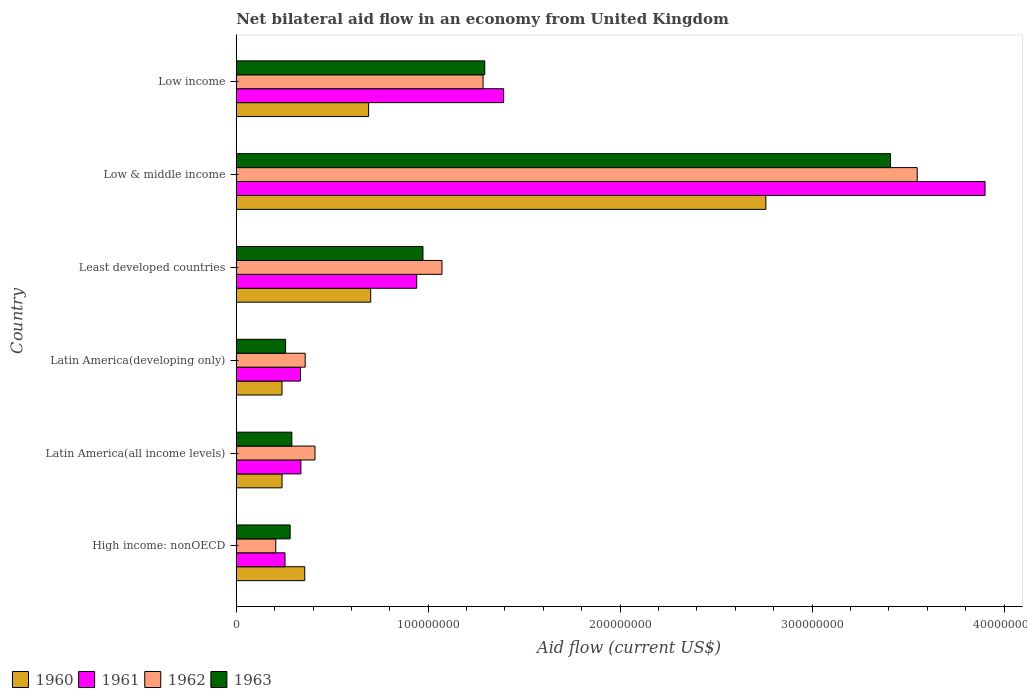How many bars are there on the 2nd tick from the top?
Make the answer very short. 4. How many bars are there on the 6th tick from the bottom?
Offer a terse response. 4. What is the label of the 5th group of bars from the top?
Offer a very short reply. Latin America(all income levels). In how many cases, is the number of bars for a given country not equal to the number of legend labels?
Your answer should be compact. 0. What is the net bilateral aid flow in 1963 in Least developed countries?
Your answer should be very brief. 9.73e+07. Across all countries, what is the maximum net bilateral aid flow in 1963?
Provide a succinct answer. 3.41e+08. Across all countries, what is the minimum net bilateral aid flow in 1960?
Provide a succinct answer. 2.38e+07. In which country was the net bilateral aid flow in 1960 minimum?
Provide a succinct answer. Latin America(developing only). What is the total net bilateral aid flow in 1962 in the graph?
Your answer should be compact. 6.88e+08. What is the difference between the net bilateral aid flow in 1963 in Low & middle income and that in Low income?
Ensure brevity in your answer.  2.11e+08. What is the difference between the net bilateral aid flow in 1961 in Latin America(all income levels) and the net bilateral aid flow in 1962 in Low & middle income?
Your answer should be compact. -3.21e+08. What is the average net bilateral aid flow in 1960 per country?
Your answer should be compact. 8.30e+07. What is the difference between the net bilateral aid flow in 1963 and net bilateral aid flow in 1960 in Least developed countries?
Keep it short and to the point. 2.72e+07. What is the ratio of the net bilateral aid flow in 1961 in Least developed countries to that in Low & middle income?
Your response must be concise. 0.24. Is the difference between the net bilateral aid flow in 1963 in High income: nonOECD and Low income greater than the difference between the net bilateral aid flow in 1960 in High income: nonOECD and Low income?
Your answer should be compact. No. What is the difference between the highest and the second highest net bilateral aid flow in 1962?
Make the answer very short. 2.26e+08. What is the difference between the highest and the lowest net bilateral aid flow in 1962?
Provide a succinct answer. 3.34e+08. In how many countries, is the net bilateral aid flow in 1961 greater than the average net bilateral aid flow in 1961 taken over all countries?
Provide a succinct answer. 2. What does the 3rd bar from the bottom in Latin America(all income levels) represents?
Offer a terse response. 1962. How many countries are there in the graph?
Provide a short and direct response. 6. Are the values on the major ticks of X-axis written in scientific E-notation?
Provide a short and direct response. No. Does the graph contain any zero values?
Make the answer very short. No. Where does the legend appear in the graph?
Ensure brevity in your answer.  Bottom left. How are the legend labels stacked?
Offer a very short reply. Horizontal. What is the title of the graph?
Your answer should be compact. Net bilateral aid flow in an economy from United Kingdom. Does "2001" appear as one of the legend labels in the graph?
Your answer should be very brief. No. What is the label or title of the X-axis?
Ensure brevity in your answer.  Aid flow (current US$). What is the label or title of the Y-axis?
Your answer should be compact. Country. What is the Aid flow (current US$) of 1960 in High income: nonOECD?
Your response must be concise. 3.57e+07. What is the Aid flow (current US$) in 1961 in High income: nonOECD?
Provide a succinct answer. 2.54e+07. What is the Aid flow (current US$) of 1962 in High income: nonOECD?
Your answer should be very brief. 2.06e+07. What is the Aid flow (current US$) of 1963 in High income: nonOECD?
Your answer should be compact. 2.81e+07. What is the Aid flow (current US$) of 1960 in Latin America(all income levels)?
Ensure brevity in your answer.  2.39e+07. What is the Aid flow (current US$) in 1961 in Latin America(all income levels)?
Provide a short and direct response. 3.37e+07. What is the Aid flow (current US$) of 1962 in Latin America(all income levels)?
Provide a succinct answer. 4.10e+07. What is the Aid flow (current US$) in 1963 in Latin America(all income levels)?
Ensure brevity in your answer.  2.90e+07. What is the Aid flow (current US$) of 1960 in Latin America(developing only)?
Your answer should be very brief. 2.38e+07. What is the Aid flow (current US$) of 1961 in Latin America(developing only)?
Your answer should be compact. 3.34e+07. What is the Aid flow (current US$) of 1962 in Latin America(developing only)?
Make the answer very short. 3.59e+07. What is the Aid flow (current US$) in 1963 in Latin America(developing only)?
Offer a very short reply. 2.57e+07. What is the Aid flow (current US$) in 1960 in Least developed countries?
Offer a very short reply. 7.00e+07. What is the Aid flow (current US$) in 1961 in Least developed countries?
Your response must be concise. 9.40e+07. What is the Aid flow (current US$) of 1962 in Least developed countries?
Ensure brevity in your answer.  1.07e+08. What is the Aid flow (current US$) in 1963 in Least developed countries?
Provide a succinct answer. 9.73e+07. What is the Aid flow (current US$) in 1960 in Low & middle income?
Offer a terse response. 2.76e+08. What is the Aid flow (current US$) in 1961 in Low & middle income?
Offer a very short reply. 3.90e+08. What is the Aid flow (current US$) of 1962 in Low & middle income?
Your response must be concise. 3.55e+08. What is the Aid flow (current US$) of 1963 in Low & middle income?
Provide a succinct answer. 3.41e+08. What is the Aid flow (current US$) in 1960 in Low income?
Provide a short and direct response. 6.90e+07. What is the Aid flow (current US$) in 1961 in Low income?
Your answer should be very brief. 1.39e+08. What is the Aid flow (current US$) in 1962 in Low income?
Offer a terse response. 1.29e+08. What is the Aid flow (current US$) of 1963 in Low income?
Offer a very short reply. 1.29e+08. Across all countries, what is the maximum Aid flow (current US$) in 1960?
Give a very brief answer. 2.76e+08. Across all countries, what is the maximum Aid flow (current US$) in 1961?
Provide a short and direct response. 3.90e+08. Across all countries, what is the maximum Aid flow (current US$) in 1962?
Ensure brevity in your answer.  3.55e+08. Across all countries, what is the maximum Aid flow (current US$) in 1963?
Your answer should be compact. 3.41e+08. Across all countries, what is the minimum Aid flow (current US$) of 1960?
Your response must be concise. 2.38e+07. Across all countries, what is the minimum Aid flow (current US$) of 1961?
Your answer should be compact. 2.54e+07. Across all countries, what is the minimum Aid flow (current US$) in 1962?
Your answer should be very brief. 2.06e+07. Across all countries, what is the minimum Aid flow (current US$) in 1963?
Provide a succinct answer. 2.57e+07. What is the total Aid flow (current US$) of 1960 in the graph?
Give a very brief answer. 4.98e+08. What is the total Aid flow (current US$) in 1961 in the graph?
Give a very brief answer. 7.16e+08. What is the total Aid flow (current US$) in 1962 in the graph?
Your answer should be very brief. 6.88e+08. What is the total Aid flow (current US$) of 1963 in the graph?
Ensure brevity in your answer.  6.50e+08. What is the difference between the Aid flow (current US$) of 1960 in High income: nonOECD and that in Latin America(all income levels)?
Provide a short and direct response. 1.18e+07. What is the difference between the Aid flow (current US$) of 1961 in High income: nonOECD and that in Latin America(all income levels)?
Give a very brief answer. -8.27e+06. What is the difference between the Aid flow (current US$) of 1962 in High income: nonOECD and that in Latin America(all income levels)?
Give a very brief answer. -2.04e+07. What is the difference between the Aid flow (current US$) in 1963 in High income: nonOECD and that in Latin America(all income levels)?
Offer a very short reply. -9.00e+05. What is the difference between the Aid flow (current US$) in 1960 in High income: nonOECD and that in Latin America(developing only)?
Your response must be concise. 1.18e+07. What is the difference between the Aid flow (current US$) of 1961 in High income: nonOECD and that in Latin America(developing only)?
Ensure brevity in your answer.  -8.05e+06. What is the difference between the Aid flow (current US$) of 1962 in High income: nonOECD and that in Latin America(developing only)?
Your answer should be very brief. -1.53e+07. What is the difference between the Aid flow (current US$) in 1963 in High income: nonOECD and that in Latin America(developing only)?
Your answer should be very brief. 2.35e+06. What is the difference between the Aid flow (current US$) in 1960 in High income: nonOECD and that in Least developed countries?
Your answer should be very brief. -3.44e+07. What is the difference between the Aid flow (current US$) of 1961 in High income: nonOECD and that in Least developed countries?
Provide a succinct answer. -6.86e+07. What is the difference between the Aid flow (current US$) of 1962 in High income: nonOECD and that in Least developed countries?
Provide a short and direct response. -8.66e+07. What is the difference between the Aid flow (current US$) of 1963 in High income: nonOECD and that in Least developed countries?
Provide a short and direct response. -6.92e+07. What is the difference between the Aid flow (current US$) of 1960 in High income: nonOECD and that in Low & middle income?
Offer a very short reply. -2.40e+08. What is the difference between the Aid flow (current US$) in 1961 in High income: nonOECD and that in Low & middle income?
Provide a short and direct response. -3.65e+08. What is the difference between the Aid flow (current US$) of 1962 in High income: nonOECD and that in Low & middle income?
Provide a succinct answer. -3.34e+08. What is the difference between the Aid flow (current US$) in 1963 in High income: nonOECD and that in Low & middle income?
Your answer should be very brief. -3.13e+08. What is the difference between the Aid flow (current US$) in 1960 in High income: nonOECD and that in Low income?
Offer a terse response. -3.33e+07. What is the difference between the Aid flow (current US$) of 1961 in High income: nonOECD and that in Low income?
Offer a terse response. -1.14e+08. What is the difference between the Aid flow (current US$) of 1962 in High income: nonOECD and that in Low income?
Keep it short and to the point. -1.08e+08. What is the difference between the Aid flow (current US$) in 1963 in High income: nonOECD and that in Low income?
Offer a very short reply. -1.01e+08. What is the difference between the Aid flow (current US$) in 1961 in Latin America(all income levels) and that in Latin America(developing only)?
Give a very brief answer. 2.20e+05. What is the difference between the Aid flow (current US$) in 1962 in Latin America(all income levels) and that in Latin America(developing only)?
Your response must be concise. 5.10e+06. What is the difference between the Aid flow (current US$) of 1963 in Latin America(all income levels) and that in Latin America(developing only)?
Your answer should be compact. 3.25e+06. What is the difference between the Aid flow (current US$) of 1960 in Latin America(all income levels) and that in Least developed countries?
Provide a short and direct response. -4.62e+07. What is the difference between the Aid flow (current US$) in 1961 in Latin America(all income levels) and that in Least developed countries?
Offer a terse response. -6.04e+07. What is the difference between the Aid flow (current US$) in 1962 in Latin America(all income levels) and that in Least developed countries?
Offer a terse response. -6.62e+07. What is the difference between the Aid flow (current US$) in 1963 in Latin America(all income levels) and that in Least developed countries?
Make the answer very short. -6.83e+07. What is the difference between the Aid flow (current US$) of 1960 in Latin America(all income levels) and that in Low & middle income?
Your answer should be very brief. -2.52e+08. What is the difference between the Aid flow (current US$) in 1961 in Latin America(all income levels) and that in Low & middle income?
Provide a succinct answer. -3.56e+08. What is the difference between the Aid flow (current US$) of 1962 in Latin America(all income levels) and that in Low & middle income?
Make the answer very short. -3.14e+08. What is the difference between the Aid flow (current US$) in 1963 in Latin America(all income levels) and that in Low & middle income?
Provide a short and direct response. -3.12e+08. What is the difference between the Aid flow (current US$) in 1960 in Latin America(all income levels) and that in Low income?
Give a very brief answer. -4.51e+07. What is the difference between the Aid flow (current US$) in 1961 in Latin America(all income levels) and that in Low income?
Keep it short and to the point. -1.06e+08. What is the difference between the Aid flow (current US$) of 1962 in Latin America(all income levels) and that in Low income?
Ensure brevity in your answer.  -8.76e+07. What is the difference between the Aid flow (current US$) of 1963 in Latin America(all income levels) and that in Low income?
Your response must be concise. -1.00e+08. What is the difference between the Aid flow (current US$) in 1960 in Latin America(developing only) and that in Least developed countries?
Provide a succinct answer. -4.62e+07. What is the difference between the Aid flow (current US$) of 1961 in Latin America(developing only) and that in Least developed countries?
Your answer should be compact. -6.06e+07. What is the difference between the Aid flow (current US$) in 1962 in Latin America(developing only) and that in Least developed countries?
Your answer should be compact. -7.13e+07. What is the difference between the Aid flow (current US$) of 1963 in Latin America(developing only) and that in Least developed countries?
Provide a succinct answer. -7.16e+07. What is the difference between the Aid flow (current US$) in 1960 in Latin America(developing only) and that in Low & middle income?
Provide a short and direct response. -2.52e+08. What is the difference between the Aid flow (current US$) of 1961 in Latin America(developing only) and that in Low & middle income?
Your answer should be very brief. -3.57e+08. What is the difference between the Aid flow (current US$) of 1962 in Latin America(developing only) and that in Low & middle income?
Offer a very short reply. -3.19e+08. What is the difference between the Aid flow (current US$) of 1963 in Latin America(developing only) and that in Low & middle income?
Your answer should be very brief. -3.15e+08. What is the difference between the Aid flow (current US$) of 1960 in Latin America(developing only) and that in Low income?
Your answer should be compact. -4.51e+07. What is the difference between the Aid flow (current US$) of 1961 in Latin America(developing only) and that in Low income?
Provide a short and direct response. -1.06e+08. What is the difference between the Aid flow (current US$) in 1962 in Latin America(developing only) and that in Low income?
Make the answer very short. -9.27e+07. What is the difference between the Aid flow (current US$) in 1963 in Latin America(developing only) and that in Low income?
Offer a terse response. -1.04e+08. What is the difference between the Aid flow (current US$) in 1960 in Least developed countries and that in Low & middle income?
Give a very brief answer. -2.06e+08. What is the difference between the Aid flow (current US$) of 1961 in Least developed countries and that in Low & middle income?
Provide a succinct answer. -2.96e+08. What is the difference between the Aid flow (current US$) in 1962 in Least developed countries and that in Low & middle income?
Offer a terse response. -2.48e+08. What is the difference between the Aid flow (current US$) in 1963 in Least developed countries and that in Low & middle income?
Give a very brief answer. -2.44e+08. What is the difference between the Aid flow (current US$) of 1960 in Least developed countries and that in Low income?
Offer a terse response. 1.09e+06. What is the difference between the Aid flow (current US$) of 1961 in Least developed countries and that in Low income?
Offer a terse response. -4.53e+07. What is the difference between the Aid flow (current US$) of 1962 in Least developed countries and that in Low income?
Your answer should be compact. -2.14e+07. What is the difference between the Aid flow (current US$) of 1963 in Least developed countries and that in Low income?
Provide a short and direct response. -3.22e+07. What is the difference between the Aid flow (current US$) of 1960 in Low & middle income and that in Low income?
Provide a short and direct response. 2.07e+08. What is the difference between the Aid flow (current US$) of 1961 in Low & middle income and that in Low income?
Offer a very short reply. 2.51e+08. What is the difference between the Aid flow (current US$) of 1962 in Low & middle income and that in Low income?
Provide a short and direct response. 2.26e+08. What is the difference between the Aid flow (current US$) of 1963 in Low & middle income and that in Low income?
Provide a succinct answer. 2.11e+08. What is the difference between the Aid flow (current US$) of 1960 in High income: nonOECD and the Aid flow (current US$) of 1961 in Latin America(all income levels)?
Your response must be concise. 2.01e+06. What is the difference between the Aid flow (current US$) in 1960 in High income: nonOECD and the Aid flow (current US$) in 1962 in Latin America(all income levels)?
Offer a terse response. -5.34e+06. What is the difference between the Aid flow (current US$) in 1960 in High income: nonOECD and the Aid flow (current US$) in 1963 in Latin America(all income levels)?
Make the answer very short. 6.71e+06. What is the difference between the Aid flow (current US$) of 1961 in High income: nonOECD and the Aid flow (current US$) of 1962 in Latin America(all income levels)?
Offer a terse response. -1.56e+07. What is the difference between the Aid flow (current US$) of 1961 in High income: nonOECD and the Aid flow (current US$) of 1963 in Latin America(all income levels)?
Keep it short and to the point. -3.57e+06. What is the difference between the Aid flow (current US$) of 1962 in High income: nonOECD and the Aid flow (current US$) of 1963 in Latin America(all income levels)?
Give a very brief answer. -8.38e+06. What is the difference between the Aid flow (current US$) in 1960 in High income: nonOECD and the Aid flow (current US$) in 1961 in Latin America(developing only)?
Offer a very short reply. 2.23e+06. What is the difference between the Aid flow (current US$) of 1960 in High income: nonOECD and the Aid flow (current US$) of 1963 in Latin America(developing only)?
Your answer should be very brief. 9.96e+06. What is the difference between the Aid flow (current US$) of 1961 in High income: nonOECD and the Aid flow (current US$) of 1962 in Latin America(developing only)?
Offer a very short reply. -1.05e+07. What is the difference between the Aid flow (current US$) of 1961 in High income: nonOECD and the Aid flow (current US$) of 1963 in Latin America(developing only)?
Offer a terse response. -3.20e+05. What is the difference between the Aid flow (current US$) in 1962 in High income: nonOECD and the Aid flow (current US$) in 1963 in Latin America(developing only)?
Offer a very short reply. -5.13e+06. What is the difference between the Aid flow (current US$) of 1960 in High income: nonOECD and the Aid flow (current US$) of 1961 in Least developed countries?
Provide a succinct answer. -5.83e+07. What is the difference between the Aid flow (current US$) of 1960 in High income: nonOECD and the Aid flow (current US$) of 1962 in Least developed countries?
Keep it short and to the point. -7.15e+07. What is the difference between the Aid flow (current US$) of 1960 in High income: nonOECD and the Aid flow (current US$) of 1963 in Least developed countries?
Offer a terse response. -6.16e+07. What is the difference between the Aid flow (current US$) in 1961 in High income: nonOECD and the Aid flow (current US$) in 1962 in Least developed countries?
Your answer should be very brief. -8.18e+07. What is the difference between the Aid flow (current US$) of 1961 in High income: nonOECD and the Aid flow (current US$) of 1963 in Least developed countries?
Keep it short and to the point. -7.19e+07. What is the difference between the Aid flow (current US$) in 1962 in High income: nonOECD and the Aid flow (current US$) in 1963 in Least developed countries?
Ensure brevity in your answer.  -7.67e+07. What is the difference between the Aid flow (current US$) of 1960 in High income: nonOECD and the Aid flow (current US$) of 1961 in Low & middle income?
Give a very brief answer. -3.54e+08. What is the difference between the Aid flow (current US$) in 1960 in High income: nonOECD and the Aid flow (current US$) in 1962 in Low & middle income?
Keep it short and to the point. -3.19e+08. What is the difference between the Aid flow (current US$) of 1960 in High income: nonOECD and the Aid flow (current US$) of 1963 in Low & middle income?
Offer a very short reply. -3.05e+08. What is the difference between the Aid flow (current US$) of 1961 in High income: nonOECD and the Aid flow (current US$) of 1962 in Low & middle income?
Your response must be concise. -3.29e+08. What is the difference between the Aid flow (current US$) of 1961 in High income: nonOECD and the Aid flow (current US$) of 1963 in Low & middle income?
Keep it short and to the point. -3.15e+08. What is the difference between the Aid flow (current US$) of 1962 in High income: nonOECD and the Aid flow (current US$) of 1963 in Low & middle income?
Offer a terse response. -3.20e+08. What is the difference between the Aid flow (current US$) of 1960 in High income: nonOECD and the Aid flow (current US$) of 1961 in Low income?
Offer a very short reply. -1.04e+08. What is the difference between the Aid flow (current US$) in 1960 in High income: nonOECD and the Aid flow (current US$) in 1962 in Low income?
Offer a very short reply. -9.29e+07. What is the difference between the Aid flow (current US$) in 1960 in High income: nonOECD and the Aid flow (current US$) in 1963 in Low income?
Provide a succinct answer. -9.38e+07. What is the difference between the Aid flow (current US$) of 1961 in High income: nonOECD and the Aid flow (current US$) of 1962 in Low income?
Keep it short and to the point. -1.03e+08. What is the difference between the Aid flow (current US$) in 1961 in High income: nonOECD and the Aid flow (current US$) in 1963 in Low income?
Offer a terse response. -1.04e+08. What is the difference between the Aid flow (current US$) of 1962 in High income: nonOECD and the Aid flow (current US$) of 1963 in Low income?
Provide a succinct answer. -1.09e+08. What is the difference between the Aid flow (current US$) in 1960 in Latin America(all income levels) and the Aid flow (current US$) in 1961 in Latin America(developing only)?
Your answer should be compact. -9.59e+06. What is the difference between the Aid flow (current US$) of 1960 in Latin America(all income levels) and the Aid flow (current US$) of 1962 in Latin America(developing only)?
Offer a terse response. -1.21e+07. What is the difference between the Aid flow (current US$) in 1960 in Latin America(all income levels) and the Aid flow (current US$) in 1963 in Latin America(developing only)?
Provide a short and direct response. -1.86e+06. What is the difference between the Aid flow (current US$) of 1961 in Latin America(all income levels) and the Aid flow (current US$) of 1962 in Latin America(developing only)?
Ensure brevity in your answer.  -2.25e+06. What is the difference between the Aid flow (current US$) in 1961 in Latin America(all income levels) and the Aid flow (current US$) in 1963 in Latin America(developing only)?
Your answer should be compact. 7.95e+06. What is the difference between the Aid flow (current US$) in 1962 in Latin America(all income levels) and the Aid flow (current US$) in 1963 in Latin America(developing only)?
Provide a short and direct response. 1.53e+07. What is the difference between the Aid flow (current US$) in 1960 in Latin America(all income levels) and the Aid flow (current US$) in 1961 in Least developed countries?
Offer a terse response. -7.02e+07. What is the difference between the Aid flow (current US$) in 1960 in Latin America(all income levels) and the Aid flow (current US$) in 1962 in Least developed countries?
Your answer should be very brief. -8.33e+07. What is the difference between the Aid flow (current US$) of 1960 in Latin America(all income levels) and the Aid flow (current US$) of 1963 in Least developed countries?
Provide a succinct answer. -7.34e+07. What is the difference between the Aid flow (current US$) of 1961 in Latin America(all income levels) and the Aid flow (current US$) of 1962 in Least developed countries?
Your answer should be compact. -7.35e+07. What is the difference between the Aid flow (current US$) of 1961 in Latin America(all income levels) and the Aid flow (current US$) of 1963 in Least developed countries?
Offer a very short reply. -6.36e+07. What is the difference between the Aid flow (current US$) of 1962 in Latin America(all income levels) and the Aid flow (current US$) of 1963 in Least developed countries?
Your response must be concise. -5.62e+07. What is the difference between the Aid flow (current US$) in 1960 in Latin America(all income levels) and the Aid flow (current US$) in 1961 in Low & middle income?
Make the answer very short. -3.66e+08. What is the difference between the Aid flow (current US$) of 1960 in Latin America(all income levels) and the Aid flow (current US$) of 1962 in Low & middle income?
Your answer should be compact. -3.31e+08. What is the difference between the Aid flow (current US$) in 1960 in Latin America(all income levels) and the Aid flow (current US$) in 1963 in Low & middle income?
Your answer should be compact. -3.17e+08. What is the difference between the Aid flow (current US$) of 1961 in Latin America(all income levels) and the Aid flow (current US$) of 1962 in Low & middle income?
Keep it short and to the point. -3.21e+08. What is the difference between the Aid flow (current US$) of 1961 in Latin America(all income levels) and the Aid flow (current US$) of 1963 in Low & middle income?
Offer a very short reply. -3.07e+08. What is the difference between the Aid flow (current US$) in 1962 in Latin America(all income levels) and the Aid flow (current US$) in 1963 in Low & middle income?
Offer a terse response. -3.00e+08. What is the difference between the Aid flow (current US$) in 1960 in Latin America(all income levels) and the Aid flow (current US$) in 1961 in Low income?
Offer a very short reply. -1.15e+08. What is the difference between the Aid flow (current US$) of 1960 in Latin America(all income levels) and the Aid flow (current US$) of 1962 in Low income?
Offer a terse response. -1.05e+08. What is the difference between the Aid flow (current US$) in 1960 in Latin America(all income levels) and the Aid flow (current US$) in 1963 in Low income?
Your response must be concise. -1.06e+08. What is the difference between the Aid flow (current US$) of 1961 in Latin America(all income levels) and the Aid flow (current US$) of 1962 in Low income?
Keep it short and to the point. -9.49e+07. What is the difference between the Aid flow (current US$) in 1961 in Latin America(all income levels) and the Aid flow (current US$) in 1963 in Low income?
Give a very brief answer. -9.58e+07. What is the difference between the Aid flow (current US$) in 1962 in Latin America(all income levels) and the Aid flow (current US$) in 1963 in Low income?
Provide a short and direct response. -8.84e+07. What is the difference between the Aid flow (current US$) of 1960 in Latin America(developing only) and the Aid flow (current US$) of 1961 in Least developed countries?
Give a very brief answer. -7.02e+07. What is the difference between the Aid flow (current US$) of 1960 in Latin America(developing only) and the Aid flow (current US$) of 1962 in Least developed countries?
Provide a short and direct response. -8.34e+07. What is the difference between the Aid flow (current US$) of 1960 in Latin America(developing only) and the Aid flow (current US$) of 1963 in Least developed countries?
Your answer should be compact. -7.34e+07. What is the difference between the Aid flow (current US$) of 1961 in Latin America(developing only) and the Aid flow (current US$) of 1962 in Least developed countries?
Offer a very short reply. -7.37e+07. What is the difference between the Aid flow (current US$) of 1961 in Latin America(developing only) and the Aid flow (current US$) of 1963 in Least developed countries?
Give a very brief answer. -6.38e+07. What is the difference between the Aid flow (current US$) of 1962 in Latin America(developing only) and the Aid flow (current US$) of 1963 in Least developed countries?
Provide a succinct answer. -6.14e+07. What is the difference between the Aid flow (current US$) in 1960 in Latin America(developing only) and the Aid flow (current US$) in 1961 in Low & middle income?
Your answer should be very brief. -3.66e+08. What is the difference between the Aid flow (current US$) of 1960 in Latin America(developing only) and the Aid flow (current US$) of 1962 in Low & middle income?
Ensure brevity in your answer.  -3.31e+08. What is the difference between the Aid flow (current US$) of 1960 in Latin America(developing only) and the Aid flow (current US$) of 1963 in Low & middle income?
Ensure brevity in your answer.  -3.17e+08. What is the difference between the Aid flow (current US$) of 1961 in Latin America(developing only) and the Aid flow (current US$) of 1962 in Low & middle income?
Make the answer very short. -3.21e+08. What is the difference between the Aid flow (current US$) in 1961 in Latin America(developing only) and the Aid flow (current US$) in 1963 in Low & middle income?
Your response must be concise. -3.07e+08. What is the difference between the Aid flow (current US$) of 1962 in Latin America(developing only) and the Aid flow (current US$) of 1963 in Low & middle income?
Keep it short and to the point. -3.05e+08. What is the difference between the Aid flow (current US$) in 1960 in Latin America(developing only) and the Aid flow (current US$) in 1961 in Low income?
Your answer should be compact. -1.15e+08. What is the difference between the Aid flow (current US$) in 1960 in Latin America(developing only) and the Aid flow (current US$) in 1962 in Low income?
Your answer should be very brief. -1.05e+08. What is the difference between the Aid flow (current US$) of 1960 in Latin America(developing only) and the Aid flow (current US$) of 1963 in Low income?
Your response must be concise. -1.06e+08. What is the difference between the Aid flow (current US$) in 1961 in Latin America(developing only) and the Aid flow (current US$) in 1962 in Low income?
Provide a short and direct response. -9.51e+07. What is the difference between the Aid flow (current US$) of 1961 in Latin America(developing only) and the Aid flow (current US$) of 1963 in Low income?
Offer a very short reply. -9.60e+07. What is the difference between the Aid flow (current US$) in 1962 in Latin America(developing only) and the Aid flow (current US$) in 1963 in Low income?
Offer a terse response. -9.35e+07. What is the difference between the Aid flow (current US$) of 1960 in Least developed countries and the Aid flow (current US$) of 1961 in Low & middle income?
Keep it short and to the point. -3.20e+08. What is the difference between the Aid flow (current US$) in 1960 in Least developed countries and the Aid flow (current US$) in 1962 in Low & middle income?
Your answer should be very brief. -2.85e+08. What is the difference between the Aid flow (current US$) of 1960 in Least developed countries and the Aid flow (current US$) of 1963 in Low & middle income?
Keep it short and to the point. -2.71e+08. What is the difference between the Aid flow (current US$) of 1961 in Least developed countries and the Aid flow (current US$) of 1962 in Low & middle income?
Give a very brief answer. -2.61e+08. What is the difference between the Aid flow (current US$) of 1961 in Least developed countries and the Aid flow (current US$) of 1963 in Low & middle income?
Ensure brevity in your answer.  -2.47e+08. What is the difference between the Aid flow (current US$) in 1962 in Least developed countries and the Aid flow (current US$) in 1963 in Low & middle income?
Your answer should be compact. -2.34e+08. What is the difference between the Aid flow (current US$) of 1960 in Least developed countries and the Aid flow (current US$) of 1961 in Low income?
Give a very brief answer. -6.92e+07. What is the difference between the Aid flow (current US$) of 1960 in Least developed countries and the Aid flow (current US$) of 1962 in Low income?
Make the answer very short. -5.85e+07. What is the difference between the Aid flow (current US$) in 1960 in Least developed countries and the Aid flow (current US$) in 1963 in Low income?
Your answer should be compact. -5.94e+07. What is the difference between the Aid flow (current US$) in 1961 in Least developed countries and the Aid flow (current US$) in 1962 in Low income?
Your answer should be very brief. -3.46e+07. What is the difference between the Aid flow (current US$) in 1961 in Least developed countries and the Aid flow (current US$) in 1963 in Low income?
Your response must be concise. -3.54e+07. What is the difference between the Aid flow (current US$) of 1962 in Least developed countries and the Aid flow (current US$) of 1963 in Low income?
Your response must be concise. -2.23e+07. What is the difference between the Aid flow (current US$) of 1960 in Low & middle income and the Aid flow (current US$) of 1961 in Low income?
Your answer should be compact. 1.37e+08. What is the difference between the Aid flow (current US$) in 1960 in Low & middle income and the Aid flow (current US$) in 1962 in Low income?
Offer a very short reply. 1.47e+08. What is the difference between the Aid flow (current US$) of 1960 in Low & middle income and the Aid flow (current US$) of 1963 in Low income?
Keep it short and to the point. 1.46e+08. What is the difference between the Aid flow (current US$) in 1961 in Low & middle income and the Aid flow (current US$) in 1962 in Low income?
Your response must be concise. 2.62e+08. What is the difference between the Aid flow (current US$) of 1961 in Low & middle income and the Aid flow (current US$) of 1963 in Low income?
Your answer should be compact. 2.61e+08. What is the difference between the Aid flow (current US$) of 1962 in Low & middle income and the Aid flow (current US$) of 1963 in Low income?
Provide a succinct answer. 2.25e+08. What is the average Aid flow (current US$) in 1960 per country?
Keep it short and to the point. 8.30e+07. What is the average Aid flow (current US$) of 1961 per country?
Provide a short and direct response. 1.19e+08. What is the average Aid flow (current US$) in 1962 per country?
Provide a succinct answer. 1.15e+08. What is the average Aid flow (current US$) of 1963 per country?
Your answer should be very brief. 1.08e+08. What is the difference between the Aid flow (current US$) in 1960 and Aid flow (current US$) in 1961 in High income: nonOECD?
Provide a short and direct response. 1.03e+07. What is the difference between the Aid flow (current US$) in 1960 and Aid flow (current US$) in 1962 in High income: nonOECD?
Provide a short and direct response. 1.51e+07. What is the difference between the Aid flow (current US$) in 1960 and Aid flow (current US$) in 1963 in High income: nonOECD?
Your answer should be very brief. 7.61e+06. What is the difference between the Aid flow (current US$) in 1961 and Aid flow (current US$) in 1962 in High income: nonOECD?
Your answer should be very brief. 4.81e+06. What is the difference between the Aid flow (current US$) in 1961 and Aid flow (current US$) in 1963 in High income: nonOECD?
Your answer should be very brief. -2.67e+06. What is the difference between the Aid flow (current US$) of 1962 and Aid flow (current US$) of 1963 in High income: nonOECD?
Give a very brief answer. -7.48e+06. What is the difference between the Aid flow (current US$) of 1960 and Aid flow (current US$) of 1961 in Latin America(all income levels)?
Your response must be concise. -9.81e+06. What is the difference between the Aid flow (current US$) of 1960 and Aid flow (current US$) of 1962 in Latin America(all income levels)?
Offer a terse response. -1.72e+07. What is the difference between the Aid flow (current US$) in 1960 and Aid flow (current US$) in 1963 in Latin America(all income levels)?
Make the answer very short. -5.11e+06. What is the difference between the Aid flow (current US$) of 1961 and Aid flow (current US$) of 1962 in Latin America(all income levels)?
Keep it short and to the point. -7.35e+06. What is the difference between the Aid flow (current US$) in 1961 and Aid flow (current US$) in 1963 in Latin America(all income levels)?
Give a very brief answer. 4.70e+06. What is the difference between the Aid flow (current US$) in 1962 and Aid flow (current US$) in 1963 in Latin America(all income levels)?
Your answer should be very brief. 1.20e+07. What is the difference between the Aid flow (current US$) of 1960 and Aid flow (current US$) of 1961 in Latin America(developing only)?
Your response must be concise. -9.62e+06. What is the difference between the Aid flow (current US$) in 1960 and Aid flow (current US$) in 1962 in Latin America(developing only)?
Offer a very short reply. -1.21e+07. What is the difference between the Aid flow (current US$) in 1960 and Aid flow (current US$) in 1963 in Latin America(developing only)?
Your response must be concise. -1.89e+06. What is the difference between the Aid flow (current US$) in 1961 and Aid flow (current US$) in 1962 in Latin America(developing only)?
Your answer should be very brief. -2.47e+06. What is the difference between the Aid flow (current US$) in 1961 and Aid flow (current US$) in 1963 in Latin America(developing only)?
Give a very brief answer. 7.73e+06. What is the difference between the Aid flow (current US$) in 1962 and Aid flow (current US$) in 1963 in Latin America(developing only)?
Keep it short and to the point. 1.02e+07. What is the difference between the Aid flow (current US$) of 1960 and Aid flow (current US$) of 1961 in Least developed countries?
Keep it short and to the point. -2.40e+07. What is the difference between the Aid flow (current US$) in 1960 and Aid flow (current US$) in 1962 in Least developed countries?
Provide a succinct answer. -3.71e+07. What is the difference between the Aid flow (current US$) of 1960 and Aid flow (current US$) of 1963 in Least developed countries?
Make the answer very short. -2.72e+07. What is the difference between the Aid flow (current US$) of 1961 and Aid flow (current US$) of 1962 in Least developed countries?
Offer a very short reply. -1.32e+07. What is the difference between the Aid flow (current US$) of 1961 and Aid flow (current US$) of 1963 in Least developed countries?
Your answer should be compact. -3.25e+06. What is the difference between the Aid flow (current US$) in 1962 and Aid flow (current US$) in 1963 in Least developed countries?
Your response must be concise. 9.91e+06. What is the difference between the Aid flow (current US$) of 1960 and Aid flow (current US$) of 1961 in Low & middle income?
Ensure brevity in your answer.  -1.14e+08. What is the difference between the Aid flow (current US$) in 1960 and Aid flow (current US$) in 1962 in Low & middle income?
Your answer should be very brief. -7.88e+07. What is the difference between the Aid flow (current US$) of 1960 and Aid flow (current US$) of 1963 in Low & middle income?
Give a very brief answer. -6.49e+07. What is the difference between the Aid flow (current US$) in 1961 and Aid flow (current US$) in 1962 in Low & middle income?
Your answer should be compact. 3.54e+07. What is the difference between the Aid flow (current US$) in 1961 and Aid flow (current US$) in 1963 in Low & middle income?
Your answer should be compact. 4.93e+07. What is the difference between the Aid flow (current US$) of 1962 and Aid flow (current US$) of 1963 in Low & middle income?
Provide a succinct answer. 1.39e+07. What is the difference between the Aid flow (current US$) in 1960 and Aid flow (current US$) in 1961 in Low income?
Make the answer very short. -7.03e+07. What is the difference between the Aid flow (current US$) in 1960 and Aid flow (current US$) in 1962 in Low income?
Offer a terse response. -5.96e+07. What is the difference between the Aid flow (current US$) of 1960 and Aid flow (current US$) of 1963 in Low income?
Provide a short and direct response. -6.05e+07. What is the difference between the Aid flow (current US$) of 1961 and Aid flow (current US$) of 1962 in Low income?
Your answer should be compact. 1.07e+07. What is the difference between the Aid flow (current US$) in 1961 and Aid flow (current US$) in 1963 in Low income?
Offer a terse response. 9.83e+06. What is the difference between the Aid flow (current US$) of 1962 and Aid flow (current US$) of 1963 in Low income?
Ensure brevity in your answer.  -8.80e+05. What is the ratio of the Aid flow (current US$) in 1960 in High income: nonOECD to that in Latin America(all income levels)?
Offer a very short reply. 1.5. What is the ratio of the Aid flow (current US$) of 1961 in High income: nonOECD to that in Latin America(all income levels)?
Provide a succinct answer. 0.75. What is the ratio of the Aid flow (current US$) of 1962 in High income: nonOECD to that in Latin America(all income levels)?
Keep it short and to the point. 0.5. What is the ratio of the Aid flow (current US$) in 1963 in High income: nonOECD to that in Latin America(all income levels)?
Provide a succinct answer. 0.97. What is the ratio of the Aid flow (current US$) in 1960 in High income: nonOECD to that in Latin America(developing only)?
Offer a terse response. 1.5. What is the ratio of the Aid flow (current US$) of 1961 in High income: nonOECD to that in Latin America(developing only)?
Your response must be concise. 0.76. What is the ratio of the Aid flow (current US$) in 1962 in High income: nonOECD to that in Latin America(developing only)?
Your answer should be compact. 0.57. What is the ratio of the Aid flow (current US$) in 1963 in High income: nonOECD to that in Latin America(developing only)?
Offer a very short reply. 1.09. What is the ratio of the Aid flow (current US$) in 1960 in High income: nonOECD to that in Least developed countries?
Offer a terse response. 0.51. What is the ratio of the Aid flow (current US$) in 1961 in High income: nonOECD to that in Least developed countries?
Give a very brief answer. 0.27. What is the ratio of the Aid flow (current US$) of 1962 in High income: nonOECD to that in Least developed countries?
Provide a succinct answer. 0.19. What is the ratio of the Aid flow (current US$) in 1963 in High income: nonOECD to that in Least developed countries?
Your answer should be compact. 0.29. What is the ratio of the Aid flow (current US$) of 1960 in High income: nonOECD to that in Low & middle income?
Your answer should be compact. 0.13. What is the ratio of the Aid flow (current US$) in 1961 in High income: nonOECD to that in Low & middle income?
Ensure brevity in your answer.  0.07. What is the ratio of the Aid flow (current US$) of 1962 in High income: nonOECD to that in Low & middle income?
Ensure brevity in your answer.  0.06. What is the ratio of the Aid flow (current US$) in 1963 in High income: nonOECD to that in Low & middle income?
Offer a terse response. 0.08. What is the ratio of the Aid flow (current US$) in 1960 in High income: nonOECD to that in Low income?
Your answer should be very brief. 0.52. What is the ratio of the Aid flow (current US$) in 1961 in High income: nonOECD to that in Low income?
Your answer should be compact. 0.18. What is the ratio of the Aid flow (current US$) in 1962 in High income: nonOECD to that in Low income?
Provide a succinct answer. 0.16. What is the ratio of the Aid flow (current US$) in 1963 in High income: nonOECD to that in Low income?
Your answer should be compact. 0.22. What is the ratio of the Aid flow (current US$) of 1960 in Latin America(all income levels) to that in Latin America(developing only)?
Offer a terse response. 1. What is the ratio of the Aid flow (current US$) in 1961 in Latin America(all income levels) to that in Latin America(developing only)?
Your answer should be very brief. 1.01. What is the ratio of the Aid flow (current US$) of 1962 in Latin America(all income levels) to that in Latin America(developing only)?
Provide a short and direct response. 1.14. What is the ratio of the Aid flow (current US$) in 1963 in Latin America(all income levels) to that in Latin America(developing only)?
Give a very brief answer. 1.13. What is the ratio of the Aid flow (current US$) of 1960 in Latin America(all income levels) to that in Least developed countries?
Your answer should be compact. 0.34. What is the ratio of the Aid flow (current US$) of 1961 in Latin America(all income levels) to that in Least developed countries?
Offer a terse response. 0.36. What is the ratio of the Aid flow (current US$) in 1962 in Latin America(all income levels) to that in Least developed countries?
Provide a short and direct response. 0.38. What is the ratio of the Aid flow (current US$) of 1963 in Latin America(all income levels) to that in Least developed countries?
Provide a succinct answer. 0.3. What is the ratio of the Aid flow (current US$) of 1960 in Latin America(all income levels) to that in Low & middle income?
Offer a very short reply. 0.09. What is the ratio of the Aid flow (current US$) of 1961 in Latin America(all income levels) to that in Low & middle income?
Ensure brevity in your answer.  0.09. What is the ratio of the Aid flow (current US$) of 1962 in Latin America(all income levels) to that in Low & middle income?
Your answer should be very brief. 0.12. What is the ratio of the Aid flow (current US$) of 1963 in Latin America(all income levels) to that in Low & middle income?
Provide a succinct answer. 0.09. What is the ratio of the Aid flow (current US$) in 1960 in Latin America(all income levels) to that in Low income?
Provide a short and direct response. 0.35. What is the ratio of the Aid flow (current US$) of 1961 in Latin America(all income levels) to that in Low income?
Provide a short and direct response. 0.24. What is the ratio of the Aid flow (current US$) of 1962 in Latin America(all income levels) to that in Low income?
Give a very brief answer. 0.32. What is the ratio of the Aid flow (current US$) of 1963 in Latin America(all income levels) to that in Low income?
Offer a very short reply. 0.22. What is the ratio of the Aid flow (current US$) in 1960 in Latin America(developing only) to that in Least developed countries?
Offer a terse response. 0.34. What is the ratio of the Aid flow (current US$) of 1961 in Latin America(developing only) to that in Least developed countries?
Offer a very short reply. 0.36. What is the ratio of the Aid flow (current US$) in 1962 in Latin America(developing only) to that in Least developed countries?
Keep it short and to the point. 0.34. What is the ratio of the Aid flow (current US$) of 1963 in Latin America(developing only) to that in Least developed countries?
Your answer should be very brief. 0.26. What is the ratio of the Aid flow (current US$) of 1960 in Latin America(developing only) to that in Low & middle income?
Provide a succinct answer. 0.09. What is the ratio of the Aid flow (current US$) in 1961 in Latin America(developing only) to that in Low & middle income?
Keep it short and to the point. 0.09. What is the ratio of the Aid flow (current US$) in 1962 in Latin America(developing only) to that in Low & middle income?
Make the answer very short. 0.1. What is the ratio of the Aid flow (current US$) in 1963 in Latin America(developing only) to that in Low & middle income?
Give a very brief answer. 0.08. What is the ratio of the Aid flow (current US$) in 1960 in Latin America(developing only) to that in Low income?
Give a very brief answer. 0.35. What is the ratio of the Aid flow (current US$) in 1961 in Latin America(developing only) to that in Low income?
Provide a short and direct response. 0.24. What is the ratio of the Aid flow (current US$) of 1962 in Latin America(developing only) to that in Low income?
Your answer should be very brief. 0.28. What is the ratio of the Aid flow (current US$) in 1963 in Latin America(developing only) to that in Low income?
Your answer should be compact. 0.2. What is the ratio of the Aid flow (current US$) of 1960 in Least developed countries to that in Low & middle income?
Your response must be concise. 0.25. What is the ratio of the Aid flow (current US$) of 1961 in Least developed countries to that in Low & middle income?
Make the answer very short. 0.24. What is the ratio of the Aid flow (current US$) in 1962 in Least developed countries to that in Low & middle income?
Provide a succinct answer. 0.3. What is the ratio of the Aid flow (current US$) of 1963 in Least developed countries to that in Low & middle income?
Make the answer very short. 0.29. What is the ratio of the Aid flow (current US$) in 1960 in Least developed countries to that in Low income?
Offer a very short reply. 1.02. What is the ratio of the Aid flow (current US$) of 1961 in Least developed countries to that in Low income?
Ensure brevity in your answer.  0.68. What is the ratio of the Aid flow (current US$) of 1962 in Least developed countries to that in Low income?
Provide a short and direct response. 0.83. What is the ratio of the Aid flow (current US$) in 1963 in Least developed countries to that in Low income?
Give a very brief answer. 0.75. What is the ratio of the Aid flow (current US$) in 1960 in Low & middle income to that in Low income?
Ensure brevity in your answer.  4. What is the ratio of the Aid flow (current US$) in 1961 in Low & middle income to that in Low income?
Make the answer very short. 2.8. What is the ratio of the Aid flow (current US$) in 1962 in Low & middle income to that in Low income?
Offer a terse response. 2.76. What is the ratio of the Aid flow (current US$) in 1963 in Low & middle income to that in Low income?
Make the answer very short. 2.63. What is the difference between the highest and the second highest Aid flow (current US$) of 1960?
Keep it short and to the point. 2.06e+08. What is the difference between the highest and the second highest Aid flow (current US$) of 1961?
Offer a terse response. 2.51e+08. What is the difference between the highest and the second highest Aid flow (current US$) in 1962?
Provide a short and direct response. 2.26e+08. What is the difference between the highest and the second highest Aid flow (current US$) in 1963?
Provide a short and direct response. 2.11e+08. What is the difference between the highest and the lowest Aid flow (current US$) of 1960?
Your answer should be very brief. 2.52e+08. What is the difference between the highest and the lowest Aid flow (current US$) of 1961?
Provide a succinct answer. 3.65e+08. What is the difference between the highest and the lowest Aid flow (current US$) of 1962?
Offer a terse response. 3.34e+08. What is the difference between the highest and the lowest Aid flow (current US$) of 1963?
Give a very brief answer. 3.15e+08. 